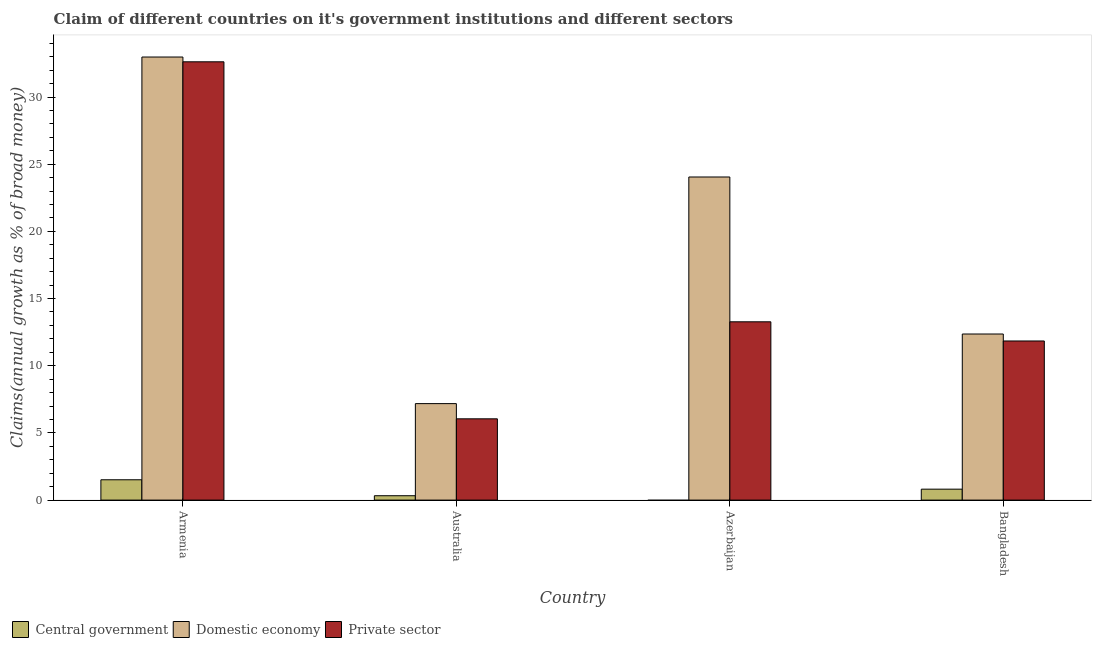How many bars are there on the 1st tick from the left?
Offer a terse response. 3. How many bars are there on the 1st tick from the right?
Provide a short and direct response. 3. What is the label of the 1st group of bars from the left?
Make the answer very short. Armenia. In how many cases, is the number of bars for a given country not equal to the number of legend labels?
Make the answer very short. 1. What is the percentage of claim on the private sector in Azerbaijan?
Your answer should be very brief. 13.27. Across all countries, what is the maximum percentage of claim on the private sector?
Ensure brevity in your answer.  32.62. Across all countries, what is the minimum percentage of claim on the central government?
Your response must be concise. 0. In which country was the percentage of claim on the domestic economy maximum?
Your answer should be very brief. Armenia. What is the total percentage of claim on the private sector in the graph?
Ensure brevity in your answer.  63.78. What is the difference between the percentage of claim on the domestic economy in Australia and that in Azerbaijan?
Offer a very short reply. -16.87. What is the difference between the percentage of claim on the central government in Bangladesh and the percentage of claim on the domestic economy in Azerbaijan?
Keep it short and to the point. -23.23. What is the average percentage of claim on the domestic economy per country?
Make the answer very short. 19.14. What is the difference between the percentage of claim on the domestic economy and percentage of claim on the central government in Armenia?
Offer a very short reply. 31.46. In how many countries, is the percentage of claim on the central government greater than 29 %?
Give a very brief answer. 0. What is the ratio of the percentage of claim on the domestic economy in Armenia to that in Azerbaijan?
Make the answer very short. 1.37. Is the difference between the percentage of claim on the domestic economy in Australia and Azerbaijan greater than the difference between the percentage of claim on the private sector in Australia and Azerbaijan?
Your answer should be compact. No. What is the difference between the highest and the second highest percentage of claim on the private sector?
Your answer should be very brief. 19.35. What is the difference between the highest and the lowest percentage of claim on the central government?
Offer a terse response. 1.51. In how many countries, is the percentage of claim on the domestic economy greater than the average percentage of claim on the domestic economy taken over all countries?
Your response must be concise. 2. Where does the legend appear in the graph?
Provide a succinct answer. Bottom left. How are the legend labels stacked?
Your response must be concise. Horizontal. What is the title of the graph?
Offer a terse response. Claim of different countries on it's government institutions and different sectors. What is the label or title of the X-axis?
Your response must be concise. Country. What is the label or title of the Y-axis?
Your answer should be compact. Claims(annual growth as % of broad money). What is the Claims(annual growth as % of broad money) of Central government in Armenia?
Give a very brief answer. 1.51. What is the Claims(annual growth as % of broad money) of Domestic economy in Armenia?
Your answer should be compact. 32.98. What is the Claims(annual growth as % of broad money) of Private sector in Armenia?
Give a very brief answer. 32.62. What is the Claims(annual growth as % of broad money) in Central government in Australia?
Your response must be concise. 0.33. What is the Claims(annual growth as % of broad money) of Domestic economy in Australia?
Offer a terse response. 7.18. What is the Claims(annual growth as % of broad money) of Private sector in Australia?
Offer a terse response. 6.05. What is the Claims(annual growth as % of broad money) in Central government in Azerbaijan?
Offer a terse response. 0. What is the Claims(annual growth as % of broad money) in Domestic economy in Azerbaijan?
Your response must be concise. 24.05. What is the Claims(annual growth as % of broad money) of Private sector in Azerbaijan?
Your response must be concise. 13.27. What is the Claims(annual growth as % of broad money) in Central government in Bangladesh?
Provide a short and direct response. 0.81. What is the Claims(annual growth as % of broad money) in Domestic economy in Bangladesh?
Your response must be concise. 12.36. What is the Claims(annual growth as % of broad money) of Private sector in Bangladesh?
Your response must be concise. 11.84. Across all countries, what is the maximum Claims(annual growth as % of broad money) in Central government?
Keep it short and to the point. 1.51. Across all countries, what is the maximum Claims(annual growth as % of broad money) of Domestic economy?
Ensure brevity in your answer.  32.98. Across all countries, what is the maximum Claims(annual growth as % of broad money) of Private sector?
Ensure brevity in your answer.  32.62. Across all countries, what is the minimum Claims(annual growth as % of broad money) in Domestic economy?
Make the answer very short. 7.18. Across all countries, what is the minimum Claims(annual growth as % of broad money) in Private sector?
Give a very brief answer. 6.05. What is the total Claims(annual growth as % of broad money) of Central government in the graph?
Your response must be concise. 2.65. What is the total Claims(annual growth as % of broad money) of Domestic economy in the graph?
Give a very brief answer. 76.57. What is the total Claims(annual growth as % of broad money) in Private sector in the graph?
Offer a terse response. 63.78. What is the difference between the Claims(annual growth as % of broad money) in Central government in Armenia and that in Australia?
Offer a terse response. 1.19. What is the difference between the Claims(annual growth as % of broad money) of Domestic economy in Armenia and that in Australia?
Ensure brevity in your answer.  25.8. What is the difference between the Claims(annual growth as % of broad money) of Private sector in Armenia and that in Australia?
Give a very brief answer. 26.57. What is the difference between the Claims(annual growth as % of broad money) of Domestic economy in Armenia and that in Azerbaijan?
Make the answer very short. 8.93. What is the difference between the Claims(annual growth as % of broad money) in Private sector in Armenia and that in Azerbaijan?
Offer a terse response. 19.35. What is the difference between the Claims(annual growth as % of broad money) in Central government in Armenia and that in Bangladesh?
Your answer should be compact. 0.7. What is the difference between the Claims(annual growth as % of broad money) of Domestic economy in Armenia and that in Bangladesh?
Offer a very short reply. 20.61. What is the difference between the Claims(annual growth as % of broad money) of Private sector in Armenia and that in Bangladesh?
Your response must be concise. 20.78. What is the difference between the Claims(annual growth as % of broad money) in Domestic economy in Australia and that in Azerbaijan?
Offer a very short reply. -16.87. What is the difference between the Claims(annual growth as % of broad money) of Private sector in Australia and that in Azerbaijan?
Offer a very short reply. -7.22. What is the difference between the Claims(annual growth as % of broad money) in Central government in Australia and that in Bangladesh?
Give a very brief answer. -0.49. What is the difference between the Claims(annual growth as % of broad money) in Domestic economy in Australia and that in Bangladesh?
Offer a very short reply. -5.18. What is the difference between the Claims(annual growth as % of broad money) of Private sector in Australia and that in Bangladesh?
Make the answer very short. -5.79. What is the difference between the Claims(annual growth as % of broad money) in Domestic economy in Azerbaijan and that in Bangladesh?
Give a very brief answer. 11.69. What is the difference between the Claims(annual growth as % of broad money) in Private sector in Azerbaijan and that in Bangladesh?
Keep it short and to the point. 1.43. What is the difference between the Claims(annual growth as % of broad money) of Central government in Armenia and the Claims(annual growth as % of broad money) of Domestic economy in Australia?
Provide a short and direct response. -5.67. What is the difference between the Claims(annual growth as % of broad money) in Central government in Armenia and the Claims(annual growth as % of broad money) in Private sector in Australia?
Give a very brief answer. -4.54. What is the difference between the Claims(annual growth as % of broad money) in Domestic economy in Armenia and the Claims(annual growth as % of broad money) in Private sector in Australia?
Provide a short and direct response. 26.93. What is the difference between the Claims(annual growth as % of broad money) in Central government in Armenia and the Claims(annual growth as % of broad money) in Domestic economy in Azerbaijan?
Provide a short and direct response. -22.54. What is the difference between the Claims(annual growth as % of broad money) of Central government in Armenia and the Claims(annual growth as % of broad money) of Private sector in Azerbaijan?
Make the answer very short. -11.76. What is the difference between the Claims(annual growth as % of broad money) in Domestic economy in Armenia and the Claims(annual growth as % of broad money) in Private sector in Azerbaijan?
Ensure brevity in your answer.  19.71. What is the difference between the Claims(annual growth as % of broad money) in Central government in Armenia and the Claims(annual growth as % of broad money) in Domestic economy in Bangladesh?
Give a very brief answer. -10.85. What is the difference between the Claims(annual growth as % of broad money) of Central government in Armenia and the Claims(annual growth as % of broad money) of Private sector in Bangladesh?
Your answer should be compact. -10.33. What is the difference between the Claims(annual growth as % of broad money) of Domestic economy in Armenia and the Claims(annual growth as % of broad money) of Private sector in Bangladesh?
Give a very brief answer. 21.13. What is the difference between the Claims(annual growth as % of broad money) in Central government in Australia and the Claims(annual growth as % of broad money) in Domestic economy in Azerbaijan?
Provide a short and direct response. -23.72. What is the difference between the Claims(annual growth as % of broad money) in Central government in Australia and the Claims(annual growth as % of broad money) in Private sector in Azerbaijan?
Make the answer very short. -12.95. What is the difference between the Claims(annual growth as % of broad money) of Domestic economy in Australia and the Claims(annual growth as % of broad money) of Private sector in Azerbaijan?
Offer a very short reply. -6.09. What is the difference between the Claims(annual growth as % of broad money) in Central government in Australia and the Claims(annual growth as % of broad money) in Domestic economy in Bangladesh?
Keep it short and to the point. -12.04. What is the difference between the Claims(annual growth as % of broad money) in Central government in Australia and the Claims(annual growth as % of broad money) in Private sector in Bangladesh?
Provide a short and direct response. -11.52. What is the difference between the Claims(annual growth as % of broad money) in Domestic economy in Australia and the Claims(annual growth as % of broad money) in Private sector in Bangladesh?
Your response must be concise. -4.66. What is the difference between the Claims(annual growth as % of broad money) of Domestic economy in Azerbaijan and the Claims(annual growth as % of broad money) of Private sector in Bangladesh?
Your answer should be very brief. 12.21. What is the average Claims(annual growth as % of broad money) in Central government per country?
Make the answer very short. 0.66. What is the average Claims(annual growth as % of broad money) of Domestic economy per country?
Provide a short and direct response. 19.14. What is the average Claims(annual growth as % of broad money) in Private sector per country?
Keep it short and to the point. 15.95. What is the difference between the Claims(annual growth as % of broad money) in Central government and Claims(annual growth as % of broad money) in Domestic economy in Armenia?
Make the answer very short. -31.46. What is the difference between the Claims(annual growth as % of broad money) of Central government and Claims(annual growth as % of broad money) of Private sector in Armenia?
Make the answer very short. -31.11. What is the difference between the Claims(annual growth as % of broad money) of Domestic economy and Claims(annual growth as % of broad money) of Private sector in Armenia?
Offer a terse response. 0.36. What is the difference between the Claims(annual growth as % of broad money) of Central government and Claims(annual growth as % of broad money) of Domestic economy in Australia?
Your response must be concise. -6.86. What is the difference between the Claims(annual growth as % of broad money) in Central government and Claims(annual growth as % of broad money) in Private sector in Australia?
Offer a terse response. -5.72. What is the difference between the Claims(annual growth as % of broad money) of Domestic economy and Claims(annual growth as % of broad money) of Private sector in Australia?
Your response must be concise. 1.13. What is the difference between the Claims(annual growth as % of broad money) of Domestic economy and Claims(annual growth as % of broad money) of Private sector in Azerbaijan?
Provide a succinct answer. 10.78. What is the difference between the Claims(annual growth as % of broad money) in Central government and Claims(annual growth as % of broad money) in Domestic economy in Bangladesh?
Offer a very short reply. -11.55. What is the difference between the Claims(annual growth as % of broad money) of Central government and Claims(annual growth as % of broad money) of Private sector in Bangladesh?
Provide a succinct answer. -11.03. What is the difference between the Claims(annual growth as % of broad money) of Domestic economy and Claims(annual growth as % of broad money) of Private sector in Bangladesh?
Offer a terse response. 0.52. What is the ratio of the Claims(annual growth as % of broad money) of Central government in Armenia to that in Australia?
Your response must be concise. 4.65. What is the ratio of the Claims(annual growth as % of broad money) of Domestic economy in Armenia to that in Australia?
Your response must be concise. 4.59. What is the ratio of the Claims(annual growth as % of broad money) of Private sector in Armenia to that in Australia?
Provide a succinct answer. 5.39. What is the ratio of the Claims(annual growth as % of broad money) of Domestic economy in Armenia to that in Azerbaijan?
Your answer should be very brief. 1.37. What is the ratio of the Claims(annual growth as % of broad money) in Private sector in Armenia to that in Azerbaijan?
Offer a terse response. 2.46. What is the ratio of the Claims(annual growth as % of broad money) of Central government in Armenia to that in Bangladesh?
Offer a very short reply. 1.86. What is the ratio of the Claims(annual growth as % of broad money) of Domestic economy in Armenia to that in Bangladesh?
Keep it short and to the point. 2.67. What is the ratio of the Claims(annual growth as % of broad money) of Private sector in Armenia to that in Bangladesh?
Give a very brief answer. 2.75. What is the ratio of the Claims(annual growth as % of broad money) in Domestic economy in Australia to that in Azerbaijan?
Your answer should be very brief. 0.3. What is the ratio of the Claims(annual growth as % of broad money) of Private sector in Australia to that in Azerbaijan?
Keep it short and to the point. 0.46. What is the ratio of the Claims(annual growth as % of broad money) in Central government in Australia to that in Bangladesh?
Ensure brevity in your answer.  0.4. What is the ratio of the Claims(annual growth as % of broad money) in Domestic economy in Australia to that in Bangladesh?
Your response must be concise. 0.58. What is the ratio of the Claims(annual growth as % of broad money) in Private sector in Australia to that in Bangladesh?
Give a very brief answer. 0.51. What is the ratio of the Claims(annual growth as % of broad money) in Domestic economy in Azerbaijan to that in Bangladesh?
Make the answer very short. 1.95. What is the ratio of the Claims(annual growth as % of broad money) of Private sector in Azerbaijan to that in Bangladesh?
Your answer should be compact. 1.12. What is the difference between the highest and the second highest Claims(annual growth as % of broad money) of Central government?
Offer a very short reply. 0.7. What is the difference between the highest and the second highest Claims(annual growth as % of broad money) in Domestic economy?
Your answer should be compact. 8.93. What is the difference between the highest and the second highest Claims(annual growth as % of broad money) in Private sector?
Your answer should be compact. 19.35. What is the difference between the highest and the lowest Claims(annual growth as % of broad money) in Central government?
Provide a short and direct response. 1.51. What is the difference between the highest and the lowest Claims(annual growth as % of broad money) in Domestic economy?
Make the answer very short. 25.8. What is the difference between the highest and the lowest Claims(annual growth as % of broad money) of Private sector?
Make the answer very short. 26.57. 